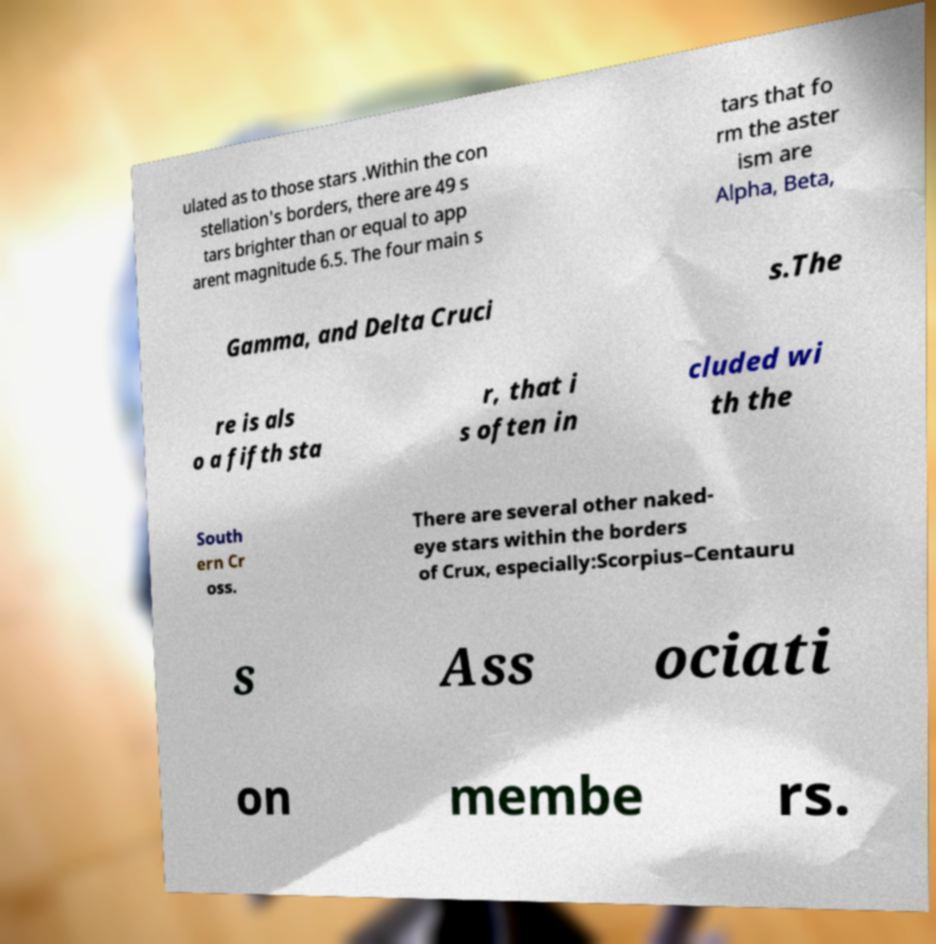Could you assist in decoding the text presented in this image and type it out clearly? ulated as to those stars .Within the con stellation's borders, there are 49 s tars brighter than or equal to app arent magnitude 6.5. The four main s tars that fo rm the aster ism are Alpha, Beta, Gamma, and Delta Cruci s.The re is als o a fifth sta r, that i s often in cluded wi th the South ern Cr oss. There are several other naked- eye stars within the borders of Crux, especially:Scorpius–Centauru s Ass ociati on membe rs. 